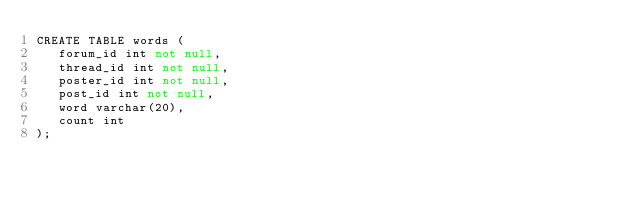Convert code to text. <code><loc_0><loc_0><loc_500><loc_500><_SQL_>CREATE TABLE words (
   forum_id int not null,
   thread_id int not null,
   poster_id int not null,
   post_id int not null,
   word varchar(20),
   count int
);

</code> 